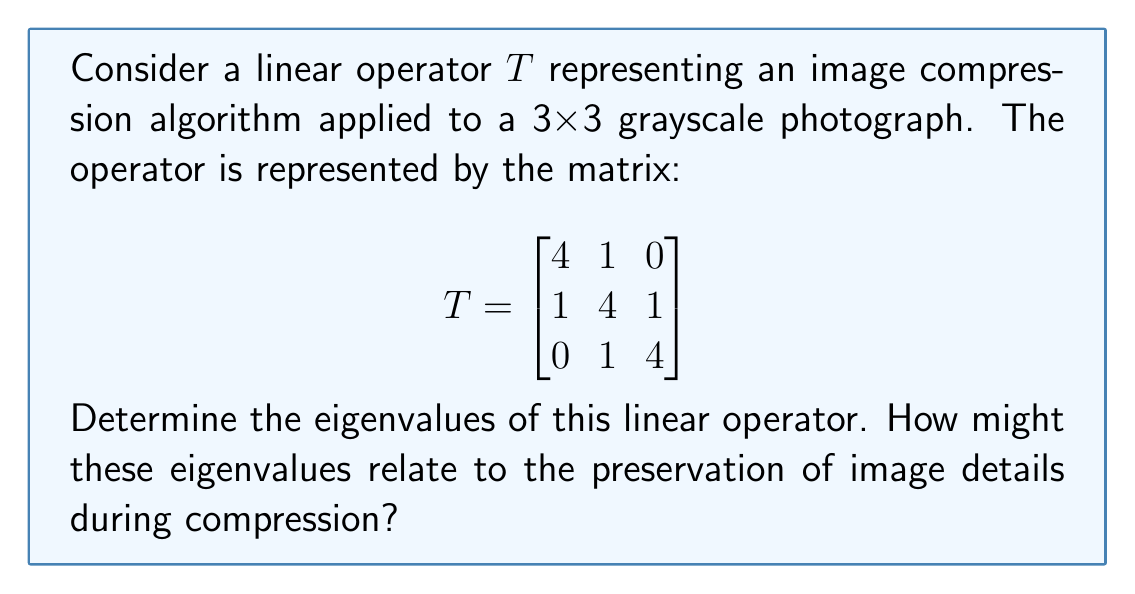Can you answer this question? To find the eigenvalues of the linear operator $T$, we follow these steps:

1) First, we need to find the characteristic polynomial of $T$. The characteristic polynomial is given by $det(T - \lambda I)$, where $I$ is the 3x3 identity matrix and $\lambda$ is a variable representing the eigenvalues.

2) Let's set up the determinant:

   $$det(T - \lambda I) = det\begin{pmatrix}
   4-\lambda & 1 & 0 \\
   1 & 4-\lambda & 1 \\
   0 & 1 & 4-\lambda
   \end{pmatrix}$$

3) Expanding this determinant:
   
   $$(4-\lambda)[(4-\lambda)(4-\lambda) - 1] - 1[1(4-\lambda) - 0] + 0$$
   
   $$= (4-\lambda)[(16-8\lambda+\lambda^2) - 1] - (4-\lambda)$$
   
   $$= (4-\lambda)(15-8\lambda+\lambda^2) - (4-\lambda)$$
   
   $$= 60 - 32\lambda + 4\lambda^2 - 15\lambda + 8\lambda^2 - \lambda^3 - 4 + \lambda$$
   
   $$= -\lambda^3 + 12\lambda^2 - 46\lambda + 56$$

4) The characteristic polynomial is therefore:

   $$p(\lambda) = -(\lambda^3 - 12\lambda^2 + 46\lambda - 56)$$

5) To find the roots of this polynomial (which are the eigenvalues), we can factor it:

   $$-(\lambda - 2)(\lambda - 5)(\lambda - 5) = 0$$

6) Solving this equation, we get the eigenvalues:

   $$\lambda_1 = 2, \lambda_2 = 5, \lambda_3 = 5$$

Regarding image compression, eigenvalues often relate to the amount of information preserved in different "directions" of the data. Larger eigenvalues (5 in this case) correspond to directions where more information is preserved, while smaller eigenvalues (2 in this case) might indicate directions where some detail is lost during compression.
Answer: $\lambda_1 = 2, \lambda_2 = \lambda_3 = 5$ 